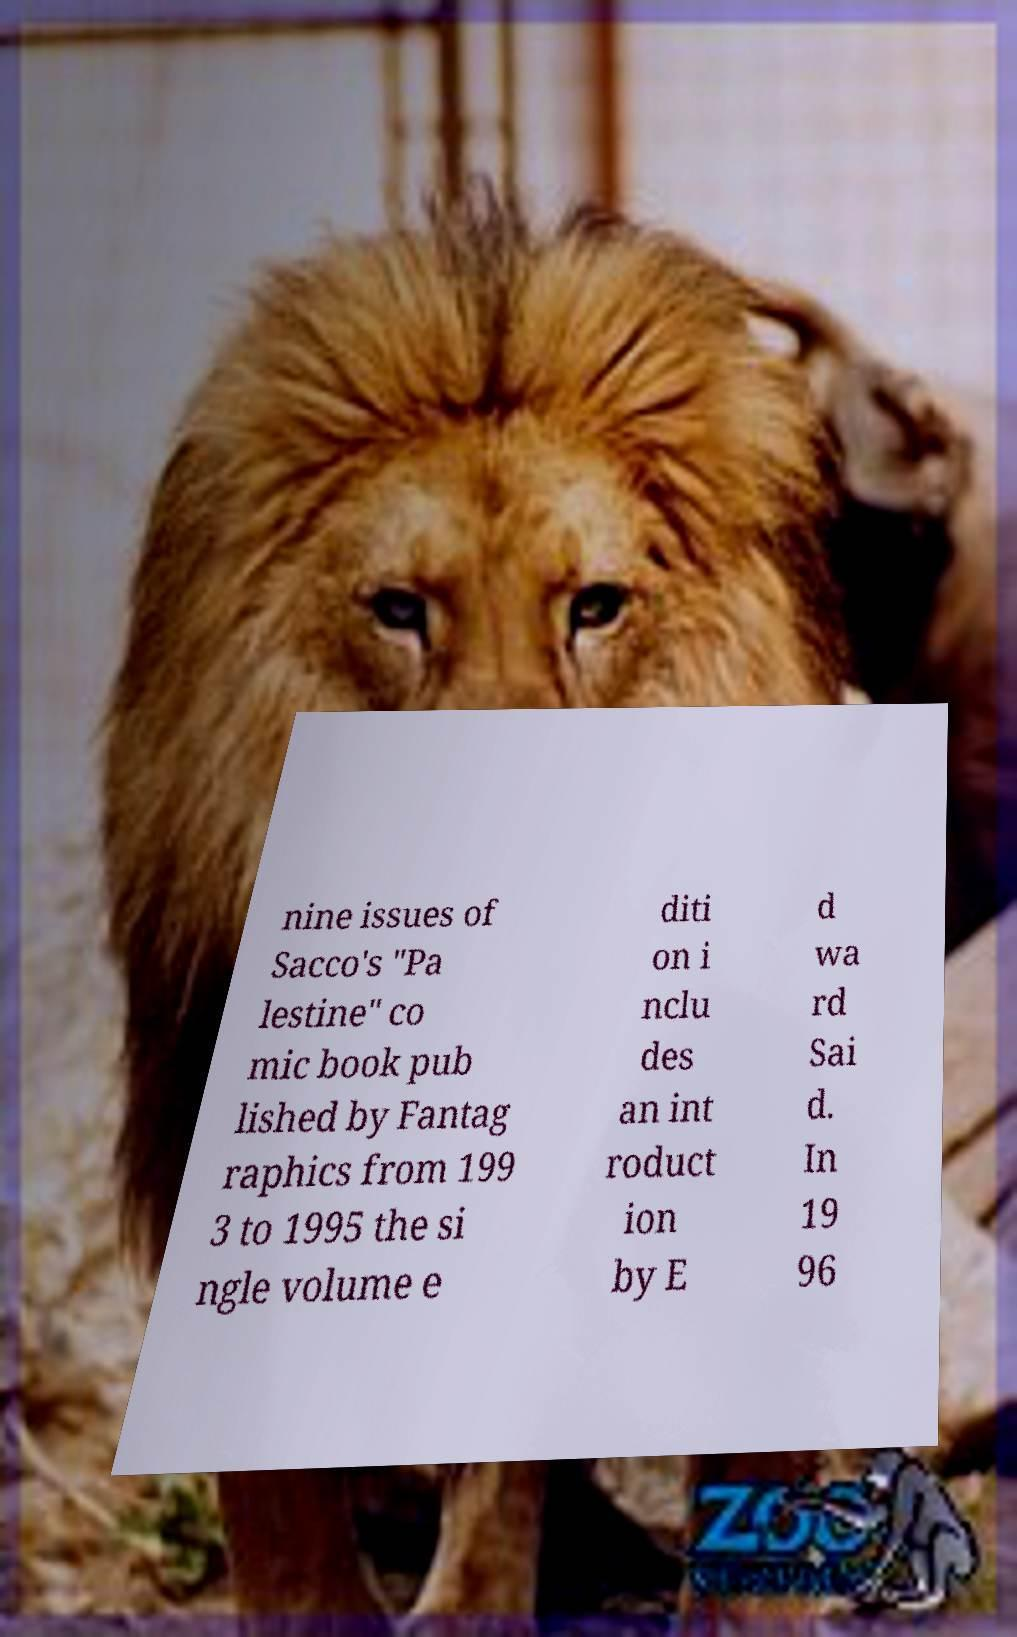Please read and relay the text visible in this image. What does it say? nine issues of Sacco's "Pa lestine" co mic book pub lished by Fantag raphics from 199 3 to 1995 the si ngle volume e diti on i nclu des an int roduct ion by E d wa rd Sai d. In 19 96 